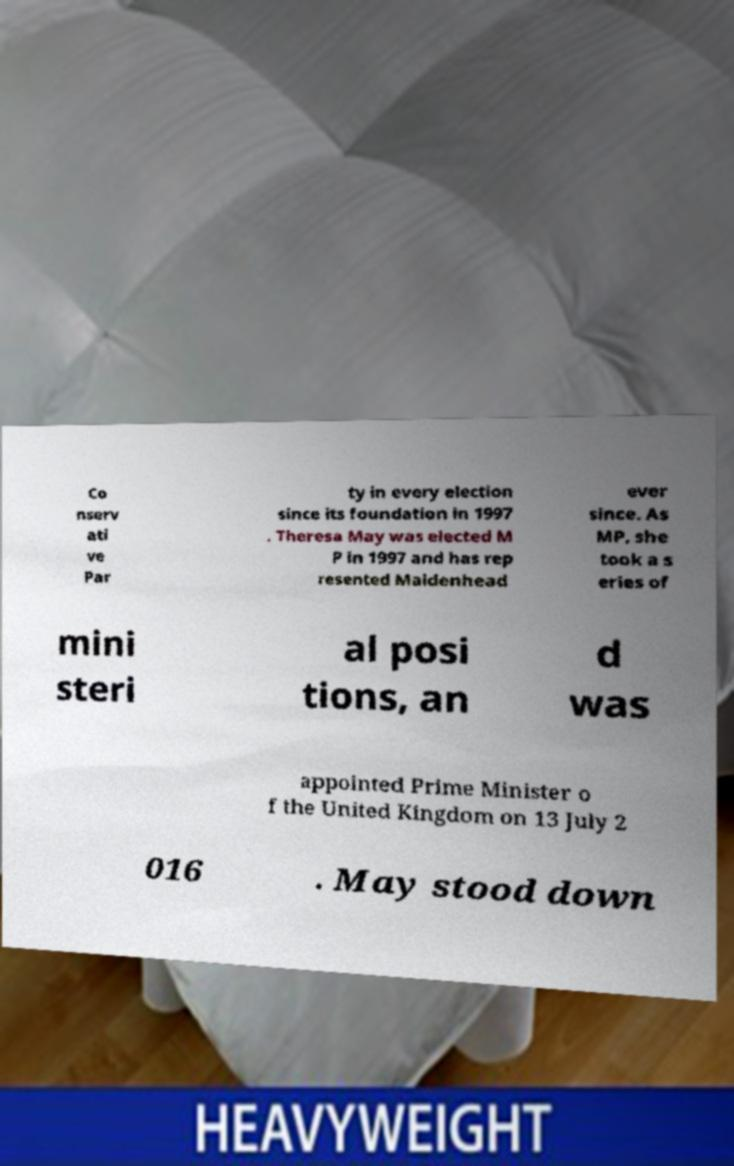I need the written content from this picture converted into text. Can you do that? Co nserv ati ve Par ty in every election since its foundation in 1997 . Theresa May was elected M P in 1997 and has rep resented Maidenhead ever since. As MP, she took a s eries of mini steri al posi tions, an d was appointed Prime Minister o f the United Kingdom on 13 July 2 016 . May stood down 